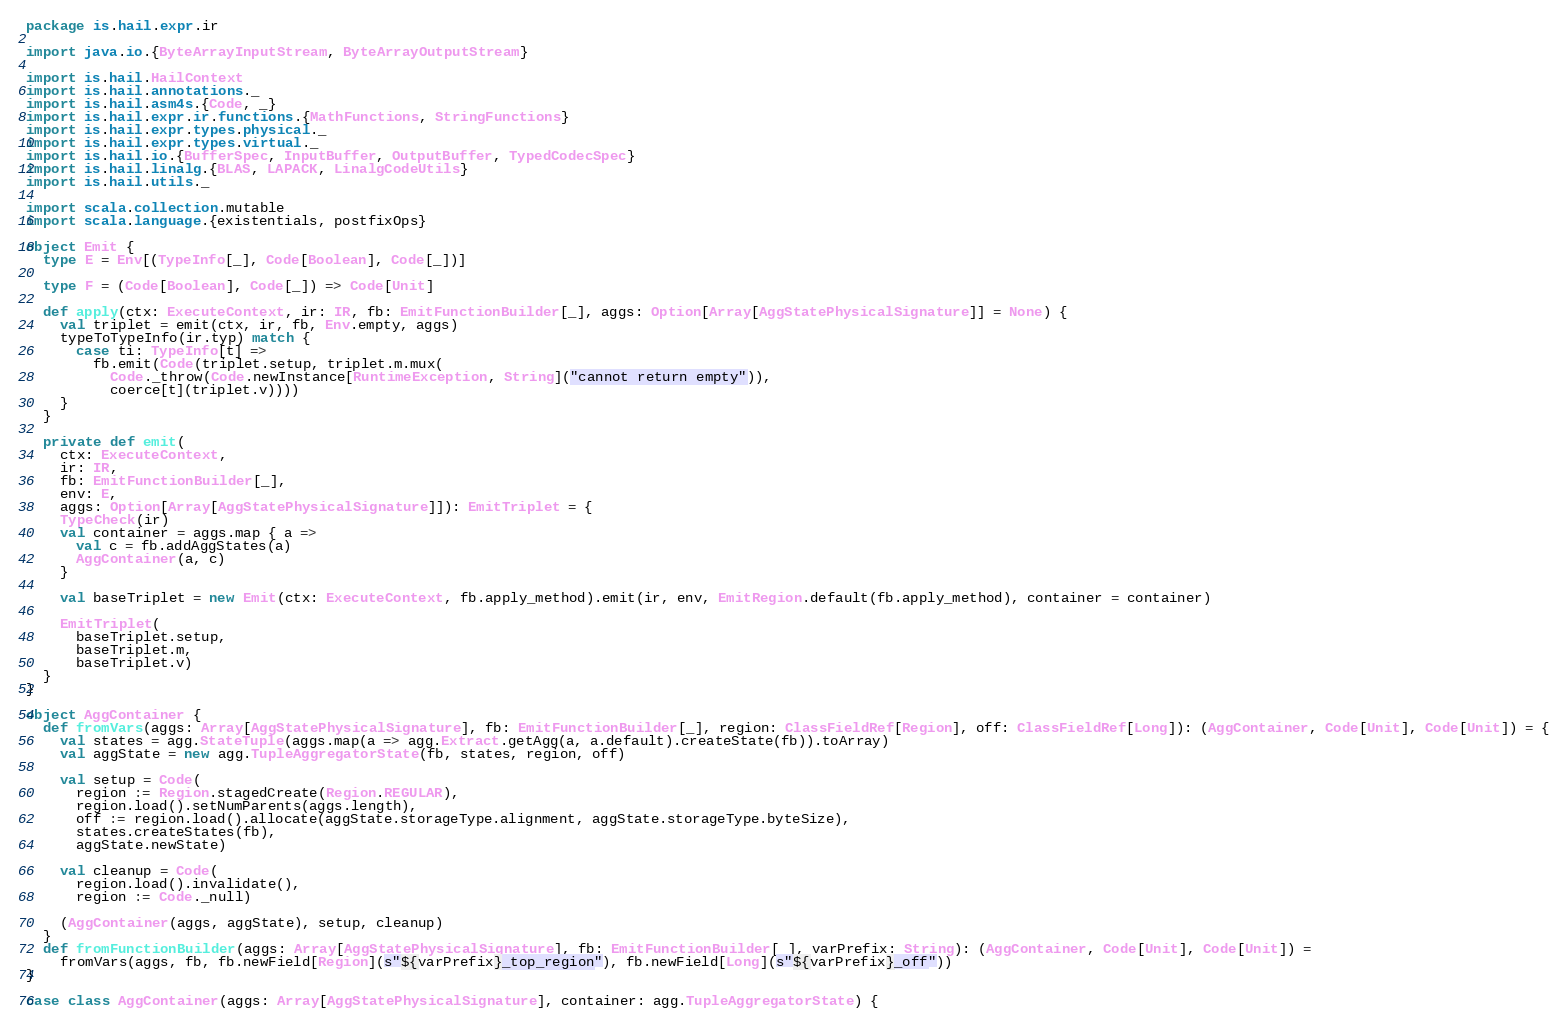<code> <loc_0><loc_0><loc_500><loc_500><_Scala_>package is.hail.expr.ir

import java.io.{ByteArrayInputStream, ByteArrayOutputStream}

import is.hail.HailContext
import is.hail.annotations._
import is.hail.asm4s.{Code, _}
import is.hail.expr.ir.functions.{MathFunctions, StringFunctions}
import is.hail.expr.types.physical._
import is.hail.expr.types.virtual._
import is.hail.io.{BufferSpec, InputBuffer, OutputBuffer, TypedCodecSpec}
import is.hail.linalg.{BLAS, LAPACK, LinalgCodeUtils}
import is.hail.utils._

import scala.collection.mutable
import scala.language.{existentials, postfixOps}

object Emit {
  type E = Env[(TypeInfo[_], Code[Boolean], Code[_])]

  type F = (Code[Boolean], Code[_]) => Code[Unit]

  def apply(ctx: ExecuteContext, ir: IR, fb: EmitFunctionBuilder[_], aggs: Option[Array[AggStatePhysicalSignature]] = None) {
    val triplet = emit(ctx, ir, fb, Env.empty, aggs)
    typeToTypeInfo(ir.typ) match {
      case ti: TypeInfo[t] =>
        fb.emit(Code(triplet.setup, triplet.m.mux(
          Code._throw(Code.newInstance[RuntimeException, String]("cannot return empty")),
          coerce[t](triplet.v))))
    }
  }

  private def emit(
    ctx: ExecuteContext,
    ir: IR,
    fb: EmitFunctionBuilder[_],
    env: E,
    aggs: Option[Array[AggStatePhysicalSignature]]): EmitTriplet = {
    TypeCheck(ir)
    val container = aggs.map { a =>
      val c = fb.addAggStates(a)
      AggContainer(a, c)
    }

    val baseTriplet = new Emit(ctx: ExecuteContext, fb.apply_method).emit(ir, env, EmitRegion.default(fb.apply_method), container = container)

    EmitTriplet(
      baseTriplet.setup,
      baseTriplet.m,
      baseTriplet.v)
  }
}

object AggContainer {
  def fromVars(aggs: Array[AggStatePhysicalSignature], fb: EmitFunctionBuilder[_], region: ClassFieldRef[Region], off: ClassFieldRef[Long]): (AggContainer, Code[Unit], Code[Unit]) = {
    val states = agg.StateTuple(aggs.map(a => agg.Extract.getAgg(a, a.default).createState(fb)).toArray)
    val aggState = new agg.TupleAggregatorState(fb, states, region, off)

    val setup = Code(
      region := Region.stagedCreate(Region.REGULAR),
      region.load().setNumParents(aggs.length),
      off := region.load().allocate(aggState.storageType.alignment, aggState.storageType.byteSize),
      states.createStates(fb),
      aggState.newState)

    val cleanup = Code(
      region.load().invalidate(),
      region := Code._null)

    (AggContainer(aggs, aggState), setup, cleanup)
  }
  def fromFunctionBuilder(aggs: Array[AggStatePhysicalSignature], fb: EmitFunctionBuilder[_], varPrefix: String): (AggContainer, Code[Unit], Code[Unit]) =
    fromVars(aggs, fb, fb.newField[Region](s"${varPrefix}_top_region"), fb.newField[Long](s"${varPrefix}_off"))
}

case class AggContainer(aggs: Array[AggStatePhysicalSignature], container: agg.TupleAggregatorState) {
</code> 